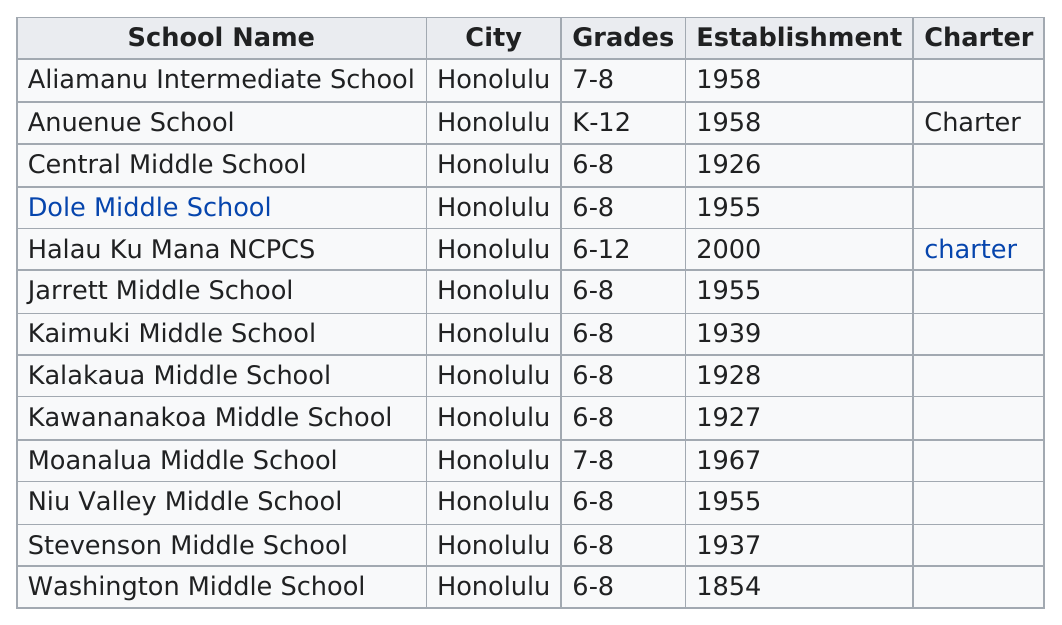Indicate a few pertinent items in this graphic. Halau Ku Mana NCPCS is either an intermediate school or a charter school, but it is not AliaMANu Intermediate School. Kalakaua Middle School has been erected for 86 years. According to the information provided, there were 6 schools established before 1955. In the 21st century, a total of 1 school was established. There are 11 schools that are not charter. 